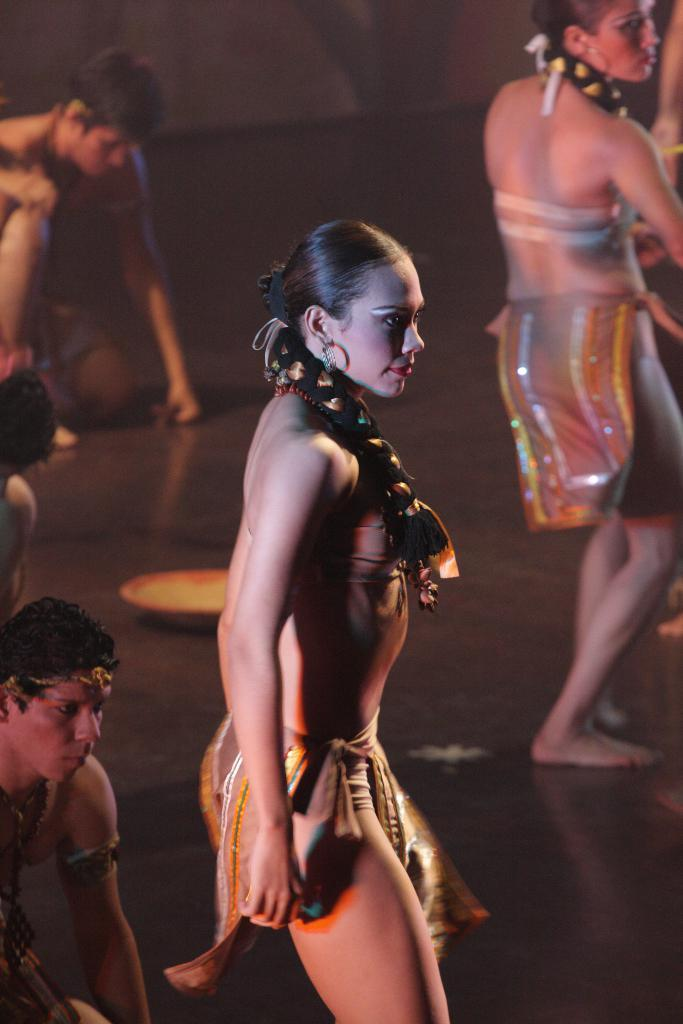What are the people in the image doing? They are dancing on a stage. What can be inferred about the gender of the people in the image? There are both women and men in the image. What is the condition of the background in the image? The background of the image is blurred. What type of veil is being used by the dancers in the image? There is no veil present in the image; the people are dancing without any such accessory. 